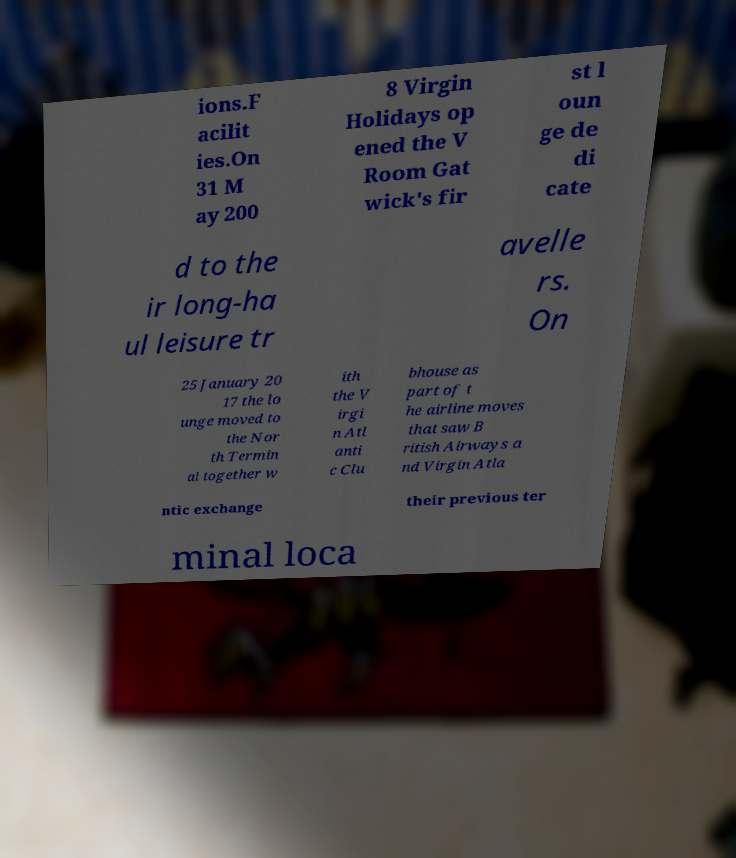Can you accurately transcribe the text from the provided image for me? ions.F acilit ies.On 31 M ay 200 8 Virgin Holidays op ened the V Room Gat wick's fir st l oun ge de di cate d to the ir long-ha ul leisure tr avelle rs. On 25 January 20 17 the lo unge moved to the Nor th Termin al together w ith the V irgi n Atl anti c Clu bhouse as part of t he airline moves that saw B ritish Airways a nd Virgin Atla ntic exchange their previous ter minal loca 